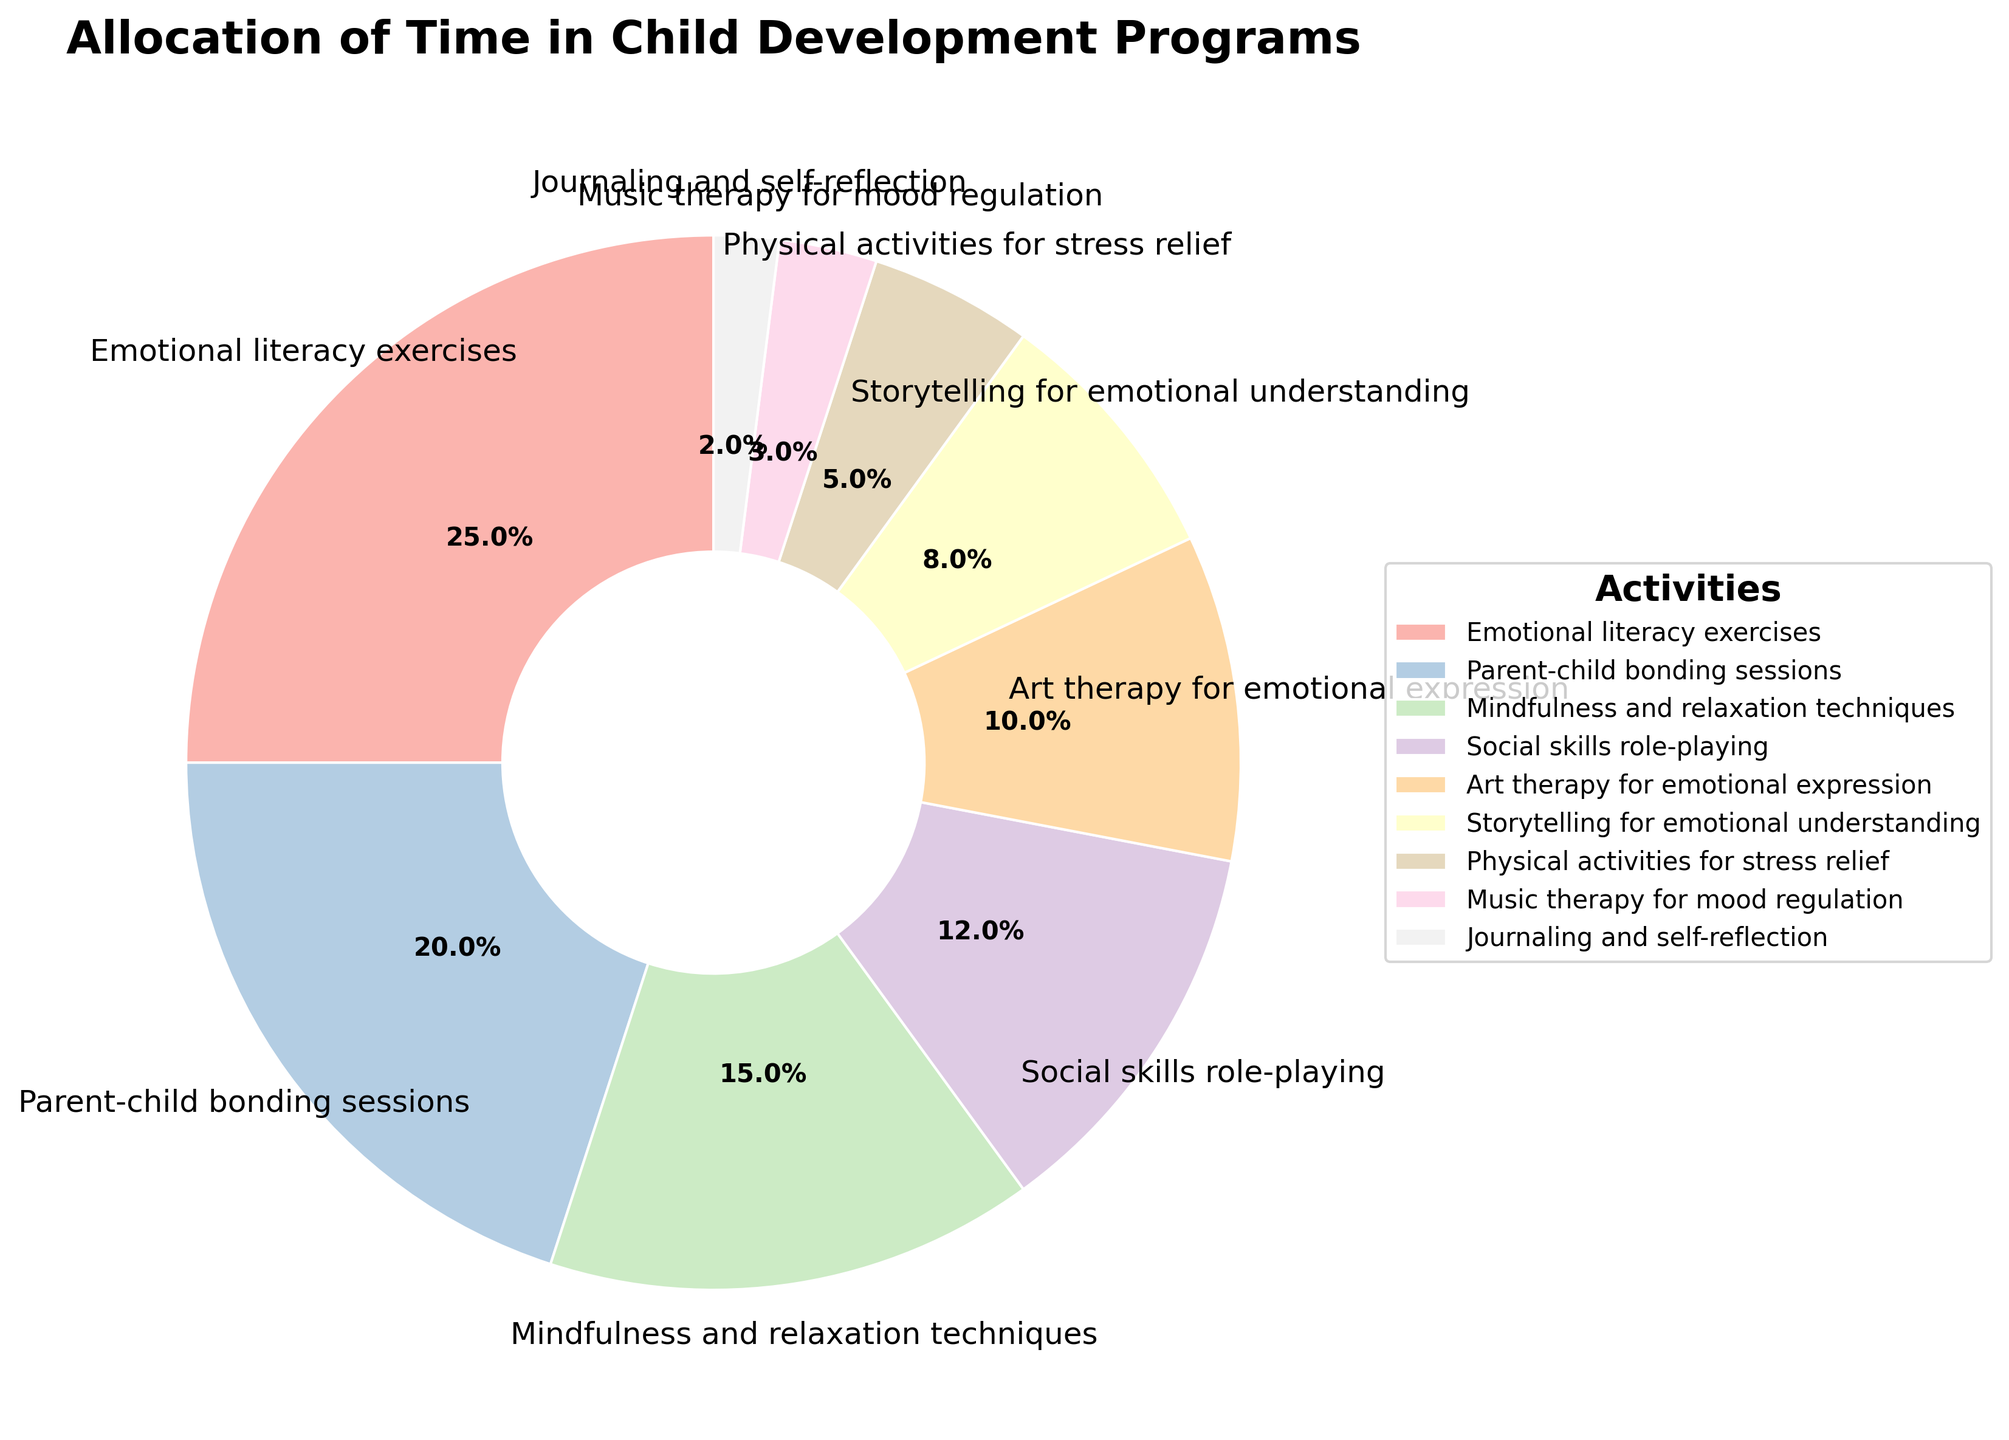Which activity has the highest percentage allocation in the chart? The activity with the highest percentage allocation is the one with the biggest slice in the pie chart. By looking at the chart, we can see that the slice labeled "Emotional literacy exercises" is the largest.
Answer: Emotional literacy exercises Which activities together represent at least 50% of the total allocation? To determine which activities together represent at least 50%, we sum the percentages starting from the largest until we reach or exceed 50%. Emotional literacy exercises (25%) + Parent-child bonding sessions (20%) = 45%. Adding Mindfulness and relaxation techniques (15%) gives us a total of 60%, which exceeds 50%.
Answer: Emotional literacy exercises, Parent-child bonding sessions, and Mindfulness and relaxation techniques Is the percentage of time allocated to Parent-child bonding sessions greater than the sum of time allocated to Music therapy and Journaling and self-reflection? First, we sum the percentages of Music therapy for mood regulation (3%) and Journaling and self-reflection (2%), which equals 5%. Then, we compare this sum with the percentage of Parent-child bonding sessions (20%). Since 20% is greater than 5%, the statement is true.
Answer: Yes What is the difference in percentage allocation between Art therapy for emotional expression and Social skills role-playing? To find the difference, we subtract the smaller percentage from the larger one: Social skills role-playing (12%) - Art therapy for emotional expression (10%) = 2%.
Answer: 2% Identify the activity with the least allocation and explain why it might be the least prioritized. The activity with the least allocation is Journaling and self-reflection, with 2%. This might be the least prioritized because it is more individualized and may be seen as less engaging or impactful compared to activities that promote group interaction or parental involvement.
Answer: Journaling and self-reflection 